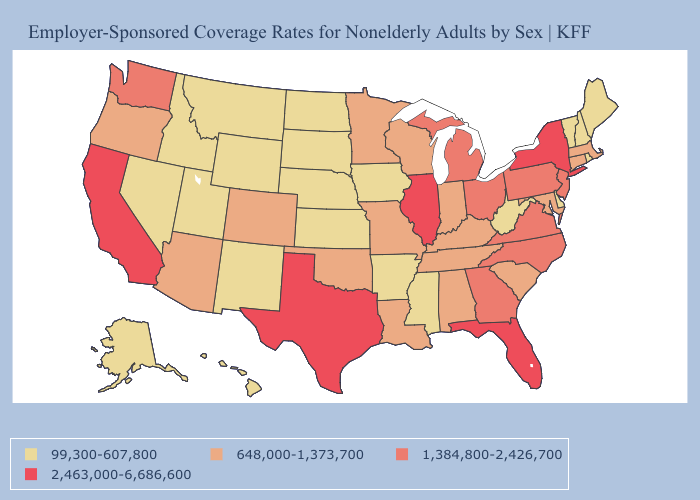Does Texas have the highest value in the South?
Keep it brief. Yes. Name the states that have a value in the range 648,000-1,373,700?
Keep it brief. Alabama, Arizona, Colorado, Connecticut, Indiana, Kentucky, Louisiana, Maryland, Massachusetts, Minnesota, Missouri, Oklahoma, Oregon, South Carolina, Tennessee, Wisconsin. Is the legend a continuous bar?
Keep it brief. No. What is the value of New York?
Answer briefly. 2,463,000-6,686,600. Which states have the lowest value in the South?
Short answer required. Arkansas, Delaware, Mississippi, West Virginia. What is the value of Hawaii?
Concise answer only. 99,300-607,800. Name the states that have a value in the range 99,300-607,800?
Give a very brief answer. Alaska, Arkansas, Delaware, Hawaii, Idaho, Iowa, Kansas, Maine, Mississippi, Montana, Nebraska, Nevada, New Hampshire, New Mexico, North Dakota, Rhode Island, South Dakota, Utah, Vermont, West Virginia, Wyoming. Name the states that have a value in the range 2,463,000-6,686,600?
Be succinct. California, Florida, Illinois, New York, Texas. What is the value of Iowa?
Be succinct. 99,300-607,800. Does Kansas have the highest value in the MidWest?
Keep it brief. No. Is the legend a continuous bar?
Concise answer only. No. Does the map have missing data?
Short answer required. No. Name the states that have a value in the range 99,300-607,800?
Keep it brief. Alaska, Arkansas, Delaware, Hawaii, Idaho, Iowa, Kansas, Maine, Mississippi, Montana, Nebraska, Nevada, New Hampshire, New Mexico, North Dakota, Rhode Island, South Dakota, Utah, Vermont, West Virginia, Wyoming. What is the value of Washington?
Write a very short answer. 1,384,800-2,426,700. Does New York have the highest value in the Northeast?
Short answer required. Yes. 